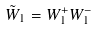Convert formula to latex. <formula><loc_0><loc_0><loc_500><loc_500>\tilde { W } _ { 1 } = W _ { 1 } ^ { + } W _ { 1 } ^ { - }</formula> 